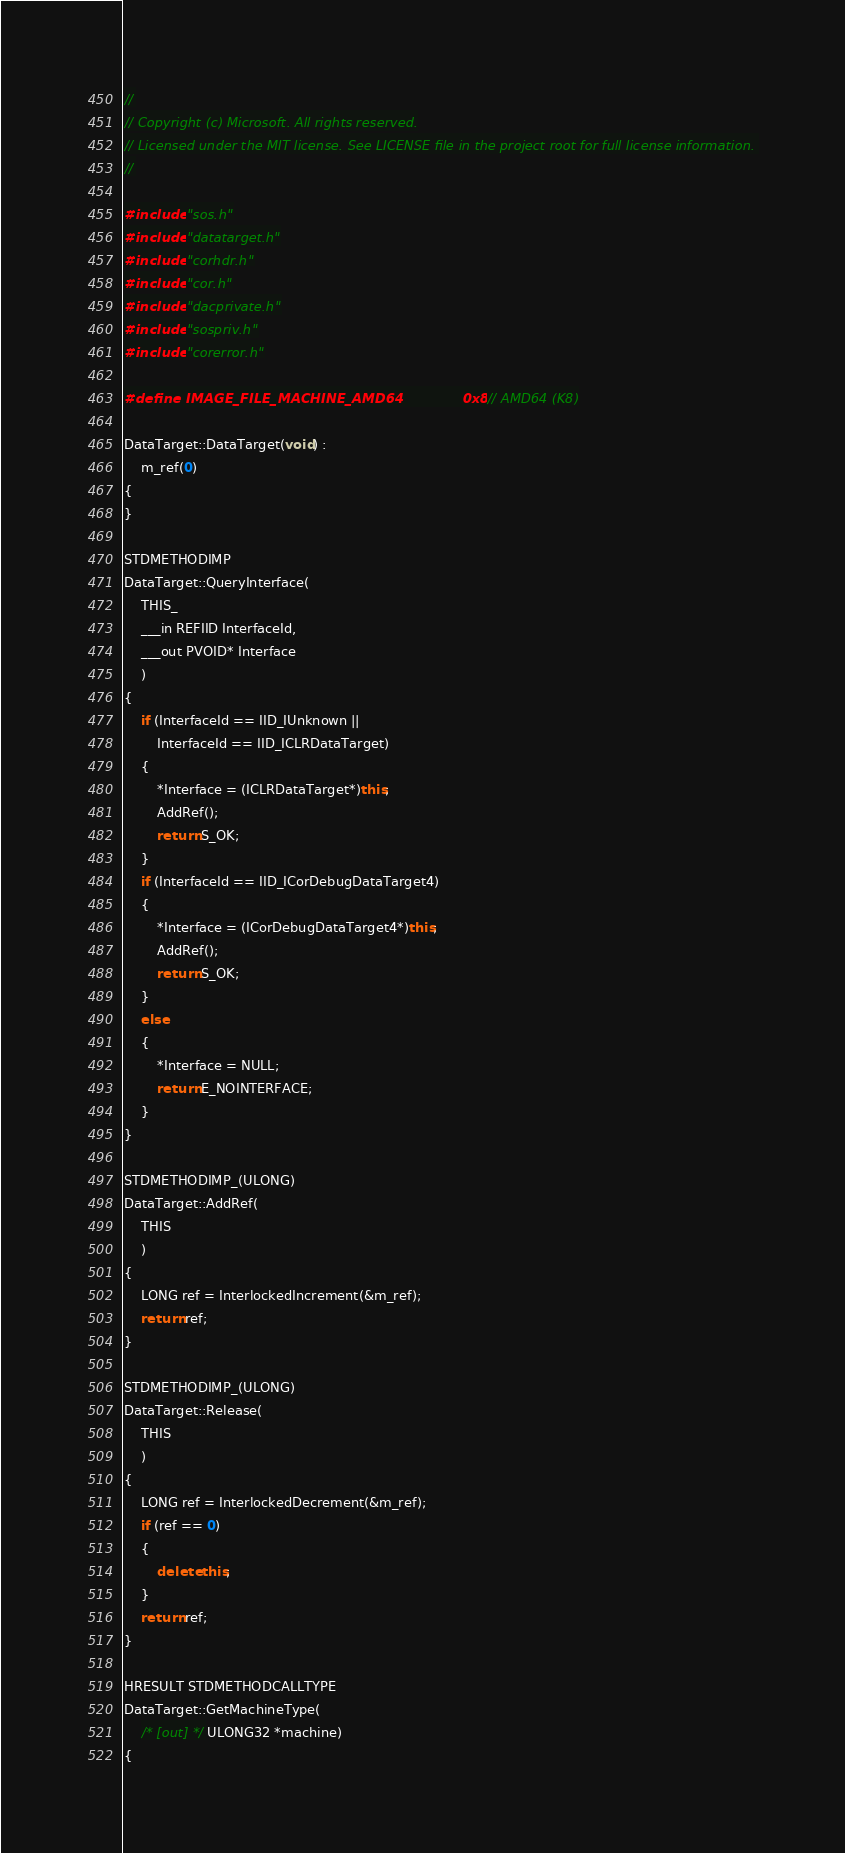<code> <loc_0><loc_0><loc_500><loc_500><_C++_>//
// Copyright (c) Microsoft. All rights reserved.
// Licensed under the MIT license. See LICENSE file in the project root for full license information. 
//

#include "sos.h"
#include "datatarget.h"
#include "corhdr.h"
#include "cor.h"
#include "dacprivate.h"
#include "sospriv.h"
#include "corerror.h"

#define IMAGE_FILE_MACHINE_AMD64             0x8664  // AMD64 (K8)

DataTarget::DataTarget(void) :
    m_ref(0)
{
}

STDMETHODIMP
DataTarget::QueryInterface(
    THIS_
    ___in REFIID InterfaceId,
    ___out PVOID* Interface
    )
{
    if (InterfaceId == IID_IUnknown ||
        InterfaceId == IID_ICLRDataTarget)
    {
        *Interface = (ICLRDataTarget*)this;
        AddRef();
        return S_OK;
    }
    if (InterfaceId == IID_ICorDebugDataTarget4)
    {
        *Interface = (ICorDebugDataTarget4*)this;
        AddRef();
        return S_OK;
    }
    else
    {
        *Interface = NULL;
        return E_NOINTERFACE;
    }
}

STDMETHODIMP_(ULONG)
DataTarget::AddRef(
    THIS
    )
{
    LONG ref = InterlockedIncrement(&m_ref);    
    return ref;
}

STDMETHODIMP_(ULONG)
DataTarget::Release(
    THIS
    )
{
    LONG ref = InterlockedDecrement(&m_ref);
    if (ref == 0)
    {
        delete this;
    }
    return ref;
}

HRESULT STDMETHODCALLTYPE
DataTarget::GetMachineType(
    /* [out] */ ULONG32 *machine)
{</code> 